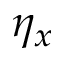<formula> <loc_0><loc_0><loc_500><loc_500>\eta _ { x }</formula> 